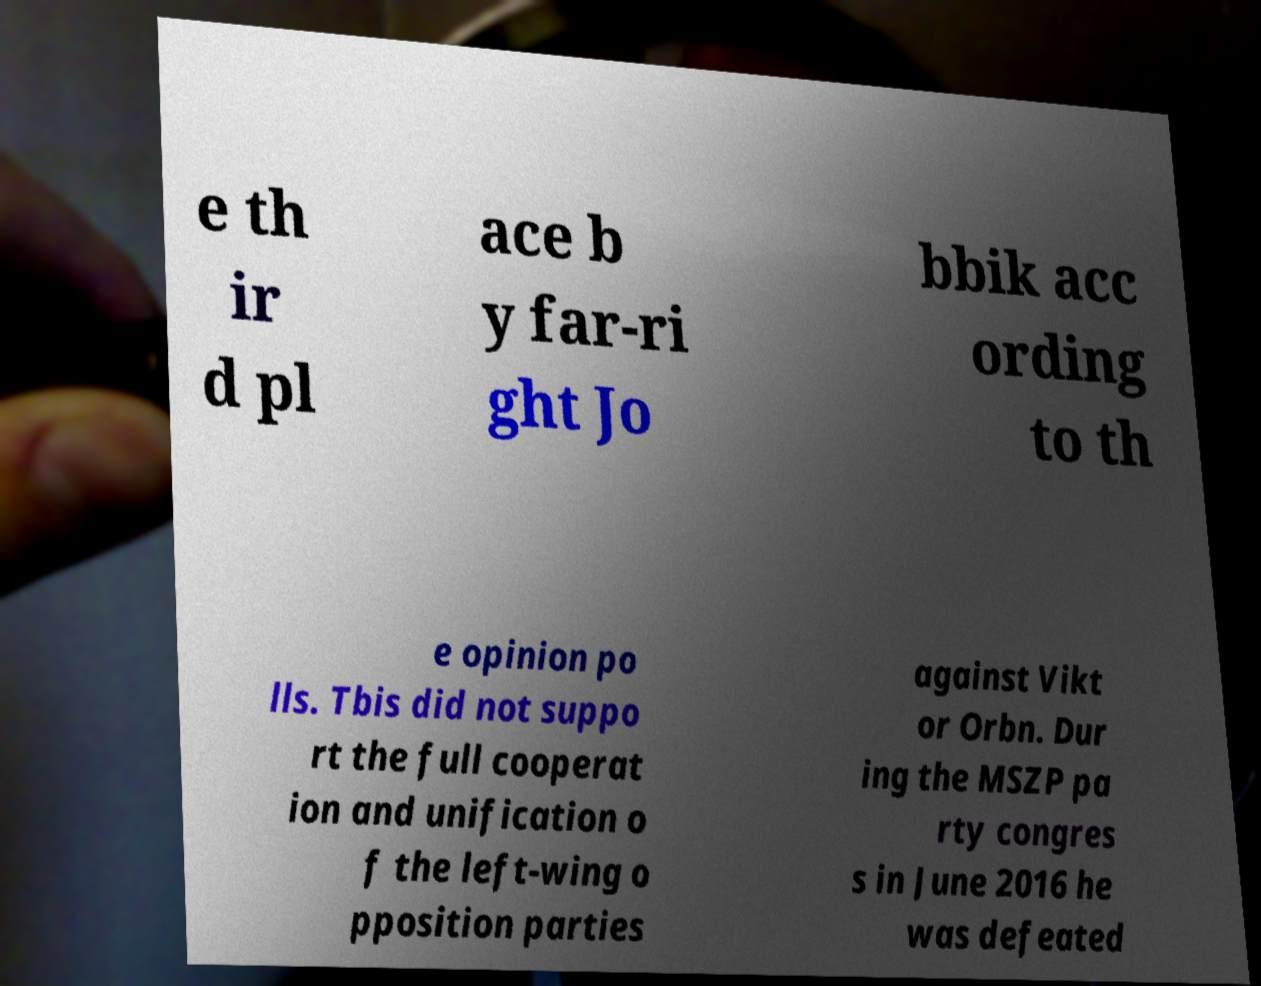Can you accurately transcribe the text from the provided image for me? e th ir d pl ace b y far-ri ght Jo bbik acc ording to th e opinion po lls. Tbis did not suppo rt the full cooperat ion and unification o f the left-wing o pposition parties against Vikt or Orbn. Dur ing the MSZP pa rty congres s in June 2016 he was defeated 